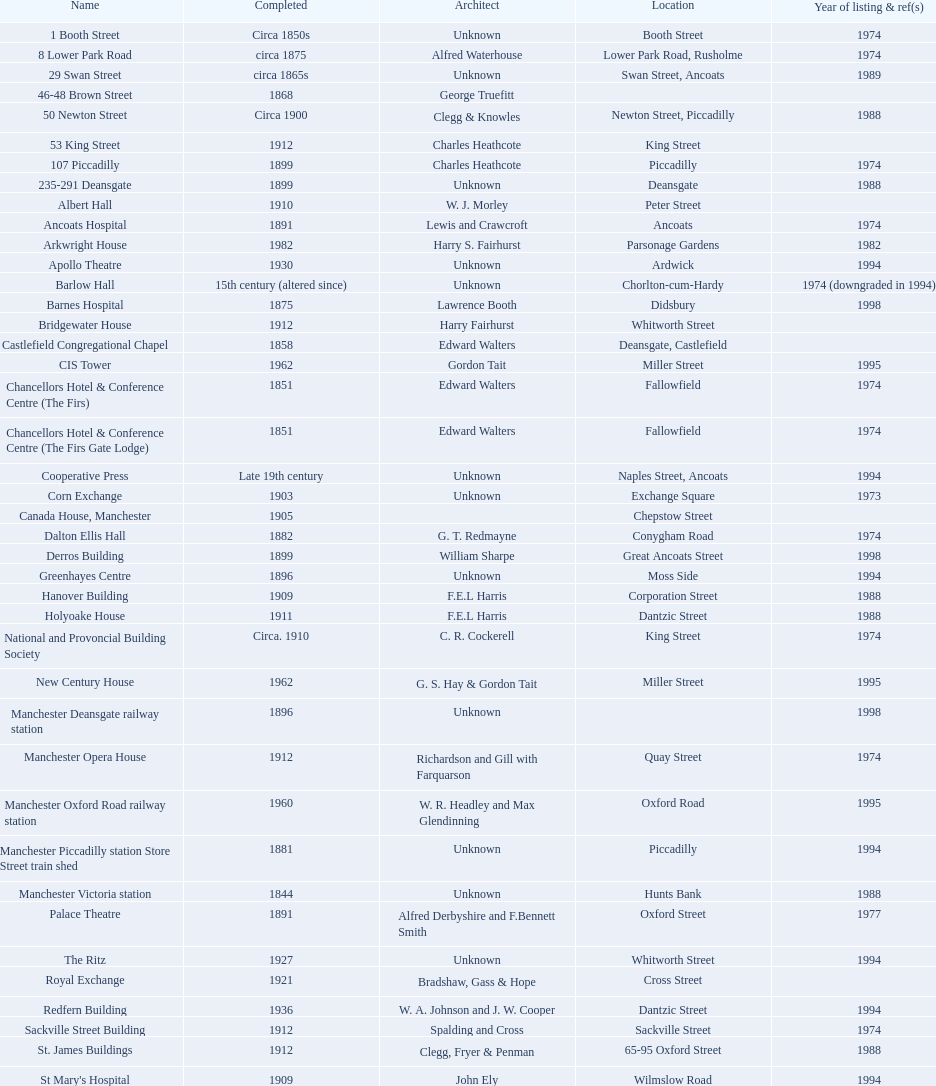What is the number of buildings without a listed image? 11. 